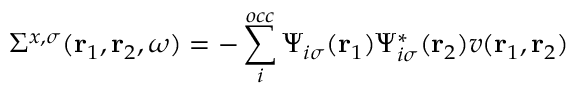Convert formula to latex. <formula><loc_0><loc_0><loc_500><loc_500>\Sigma ^ { x , \sigma } ( r _ { 1 } , r _ { 2 } , \omega ) = - \sum _ { i } ^ { o c c } \Psi _ { i \sigma } ( r _ { 1 } ) \Psi _ { i \sigma } ^ { * } ( r _ { 2 } ) v ( r _ { 1 } , r _ { 2 } )</formula> 